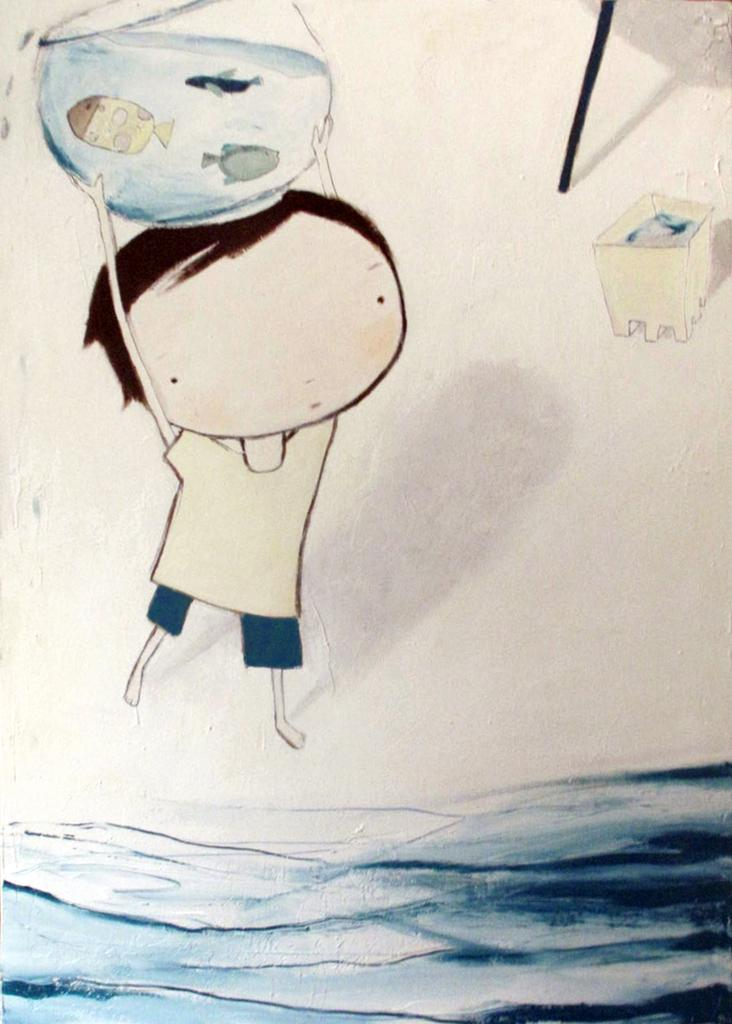What is the main subject of the image? There is an art piece in the image. What does the art piece depict? The art piece depicts a boy holding an aquarium. What is in front of the boy in the art piece? There is water in front of the boy. What can be found inside the aquarium? The aquarium contains fishes. What type of cream is being used to paint the clover in the image? There is no cream or clover present in the image; it features an art piece depicting a boy holding an aquarium. 